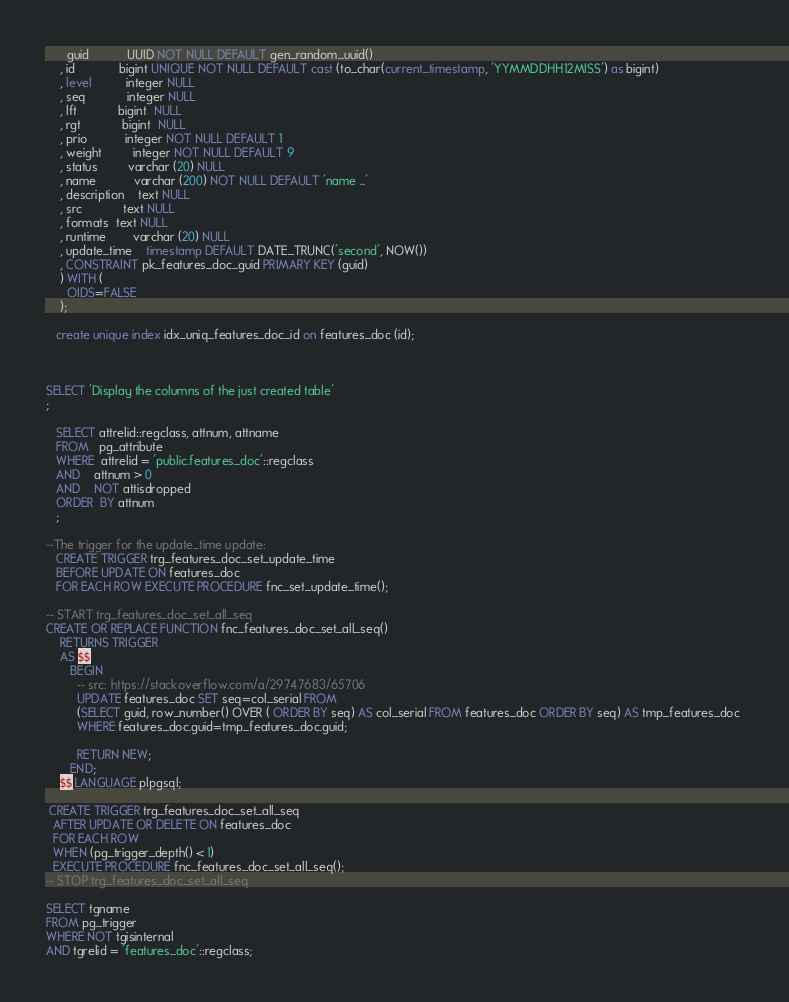<code> <loc_0><loc_0><loc_500><loc_500><_SQL_>      guid           UUID NOT NULL DEFAULT gen_random_uuid()
    , id             bigint UNIQUE NOT NULL DEFAULT cast (to_char(current_timestamp, 'YYMMDDHH12MISS') as bigint) 
    , level          integer NULL
    , seq            integer NULL
    , lft            bigint  NULL
    , rgt            bigint  NULL
    , prio           integer NOT NULL DEFAULT 1
    , weight         integer NOT NULL DEFAULT 9
    , status         varchar (20) NULL 
    , name           varchar (200) NOT NULL DEFAULT 'name ...'
    , description    text NULL
    , src            text NULL
    , formats  text NULL
    , runtime        varchar (20) NULL 
    , update_time    timestamp DEFAULT DATE_TRUNC('second', NOW())
    , CONSTRAINT pk_features_doc_guid PRIMARY KEY (guid)
    ) WITH (
      OIDS=FALSE
    );

   create unique index idx_uniq_features_doc_id on features_doc (id);



SELECT 'Display the columns of the just created table'
; 

   SELECT attrelid::regclass, attnum, attname
   FROM   pg_attribute
   WHERE  attrelid = 'public.features_doc'::regclass
   AND    attnum > 0
   AND    NOT attisdropped
   ORDER  BY attnum
   ; 

--The trigger for the update_time update: 
   CREATE TRIGGER trg_features_doc_set_update_time 
   BEFORE UPDATE ON features_doc 
   FOR EACH ROW EXECUTE PROCEDURE fnc_set_update_time();

-- START trg_features_doc_set_all_seq
CREATE OR REPLACE FUNCTION fnc_features_doc_set_all_seq()
    RETURNS TRIGGER
    AS $$
       BEGIN 
         -- src: https://stackoverflow.com/a/29747683/65706
         UPDATE features_doc SET seq=col_serial FROM 
         (SELECT guid, row_number() OVER ( ORDER BY seq) AS col_serial FROM features_doc ORDER BY seq) AS tmp_features_doc 
         WHERE features_doc.guid=tmp_features_doc.guid;

         RETURN NEW;
       END;
    $$ LANGUAGE plpgsql;

 CREATE TRIGGER trg_features_doc_set_all_seq
  AFTER UPDATE OR DELETE ON features_doc
  FOR EACH ROW 
  WHEN (pg_trigger_depth() < 1)
  EXECUTE PROCEDURE fnc_features_doc_set_all_seq();
-- STOP trg_features_doc_set_all_seq

SELECT tgname
FROM pg_trigger
WHERE NOT tgisinternal
AND tgrelid = 'features_doc'::regclass;

</code> 